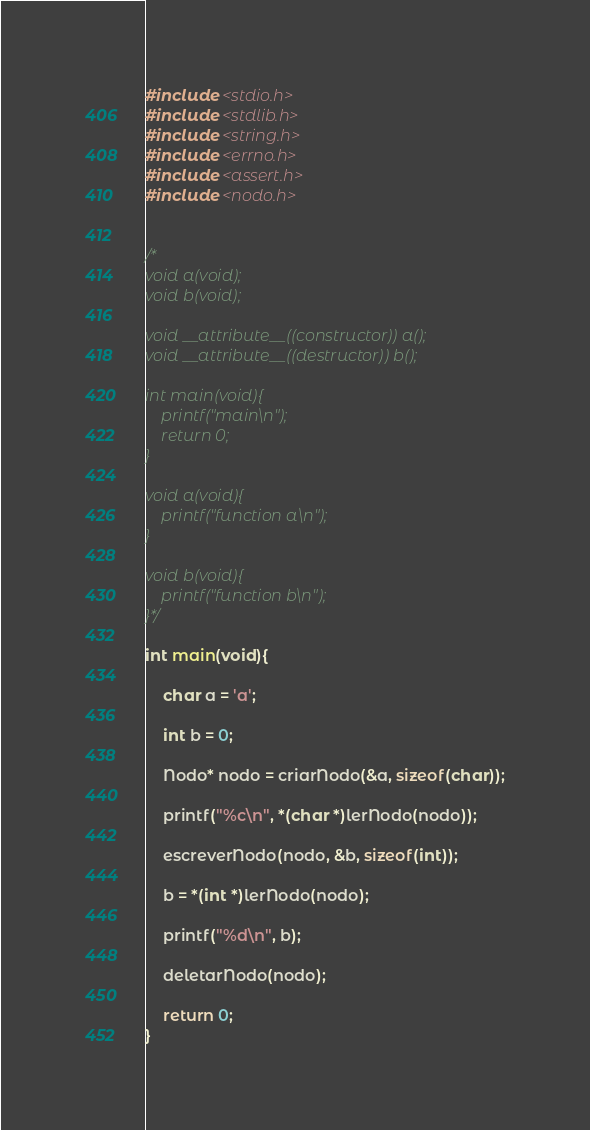Convert code to text. <code><loc_0><loc_0><loc_500><loc_500><_C_>#include <stdio.h>
#include <stdlib.h>
#include <string.h>
#include <errno.h>
#include <assert.h>
#include <nodo.h>


/*
void a(void);
void b(void);

void __attribute__((constructor)) a();
void __attribute__((destructor)) b();

int main(void){
	printf("main\n");
	return 0;
}

void a(void){
	printf("function a\n");
}

void b(void){
	printf("function b\n");
}*/

int main(void){
	
	char a = 'a';
	
	int b = 0;
	
	Nodo* nodo = criarNodo(&a, sizeof(char));
	
	printf("%c\n", *(char *)lerNodo(nodo));
	
	escreverNodo(nodo, &b, sizeof(int));
	
	b = *(int *)lerNodo(nodo);
	
	printf("%d\n", b);
	
	deletarNodo(nodo);
	
	return 0; 
}










</code> 